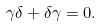Convert formula to latex. <formula><loc_0><loc_0><loc_500><loc_500>\gamma \delta + \delta \gamma = 0 .</formula> 